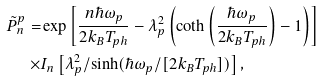Convert formula to latex. <formula><loc_0><loc_0><loc_500><loc_500>\tilde { P } ^ { p } _ { n } = & \exp \left [ \frac { n \hbar { \omega } _ { p } } { 2 k _ { B } T _ { p h } } - \lambda _ { p } ^ { 2 } \left ( \coth \left ( \frac { \hbar { \omega } _ { p } } { 2 k _ { B } T _ { p h } } \right ) - 1 \right ) \right ] \\ \times & I _ { n } \left [ \lambda _ { p } ^ { 2 } / \sinh ( \hbar { \omega } _ { p } / [ 2 k _ { B } T _ { p h } ] ) \right ] ,</formula> 